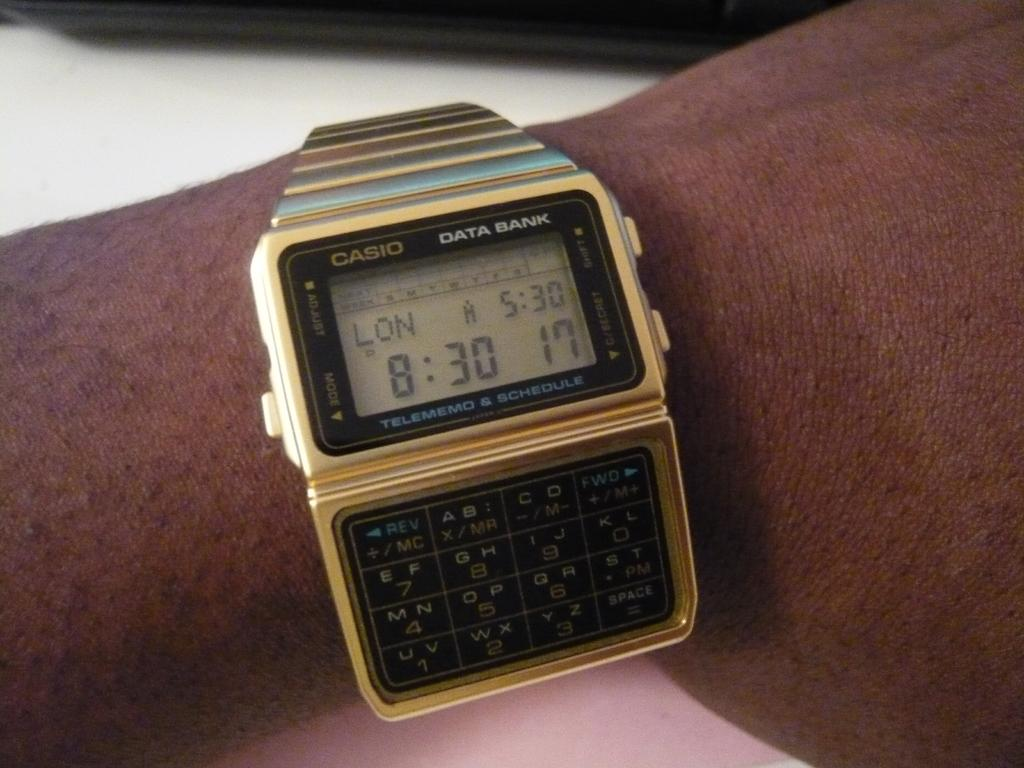<image>
Provide a brief description of the given image. A Casio watch on a wrist with the number 8 on it. 